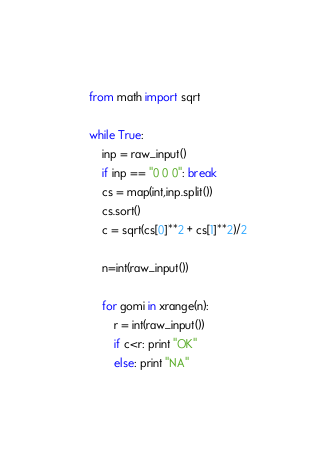Convert code to text. <code><loc_0><loc_0><loc_500><loc_500><_Python_>from math import sqrt

while True:
    inp = raw_input()
    if inp == "0 0 0": break
    cs = map(int,inp.split())
    cs.sort()
    c = sqrt(cs[0]**2 + cs[1]**2)/2

    n=int(raw_input())

    for gomi in xrange(n):
        r = int(raw_input())
        if c<r: print "OK"
        else: print "NA"</code> 